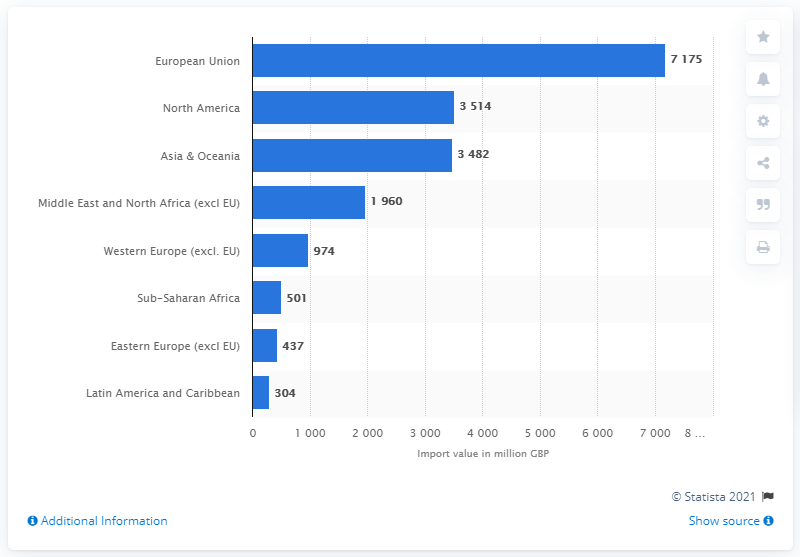List a handful of essential elements in this visual. In 2018, Wales imported a total of 3514 pounds of goods from North America. 